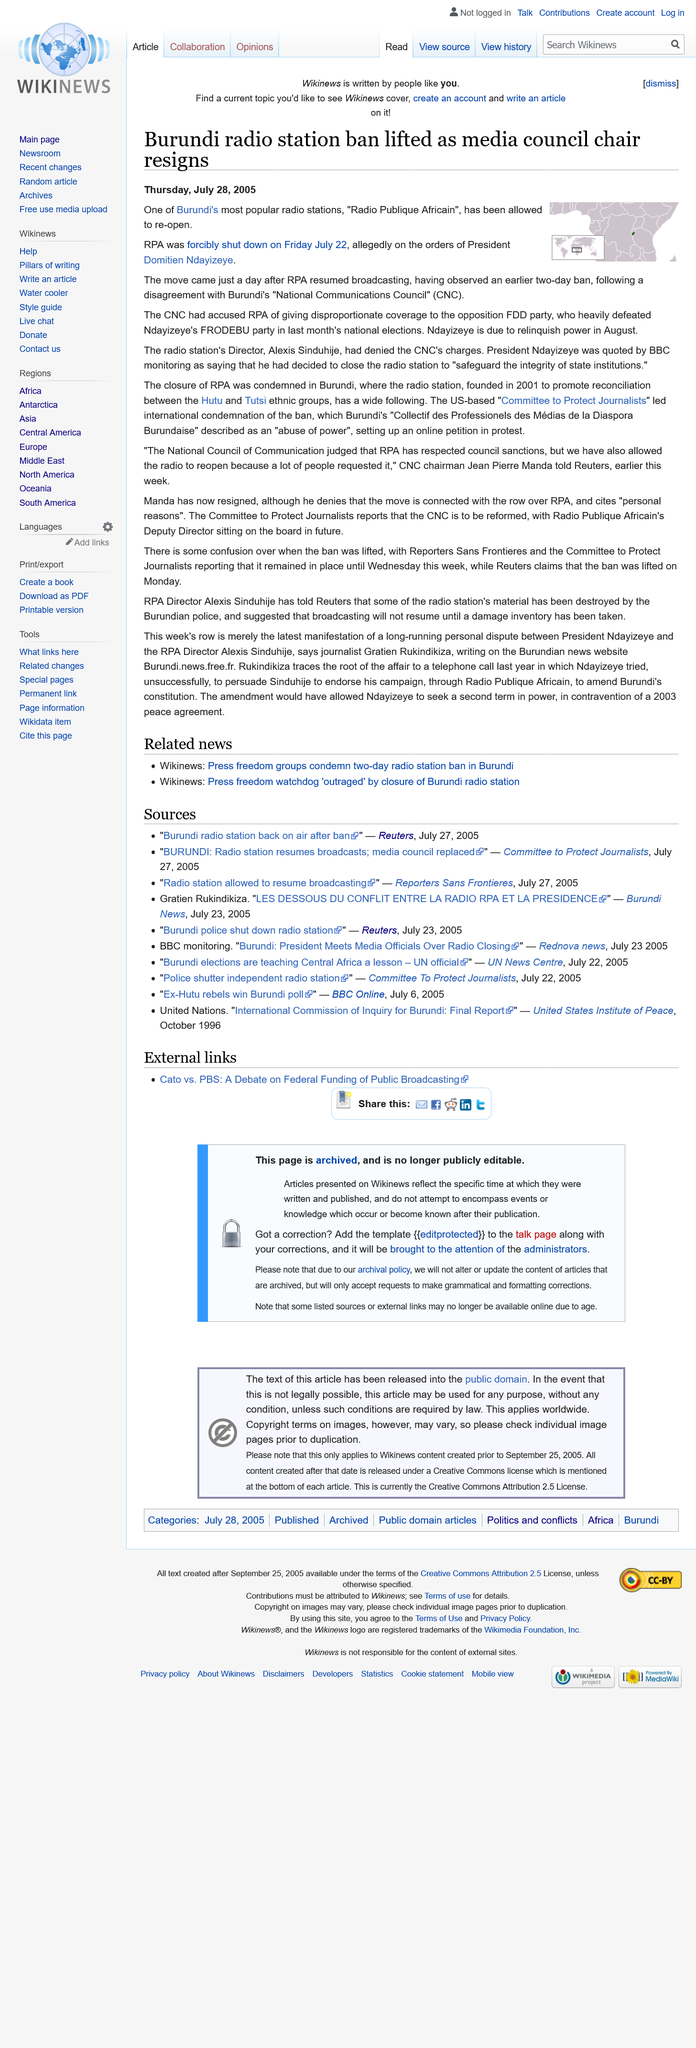Mention a couple of crucial points in this snapshot. Radio Publique Africain is the official radio station of the Republic of the Congo. Alexis Sinduhije is the director of the RPA. RPA was forcibly shut down on Friday July 22, 2005. 